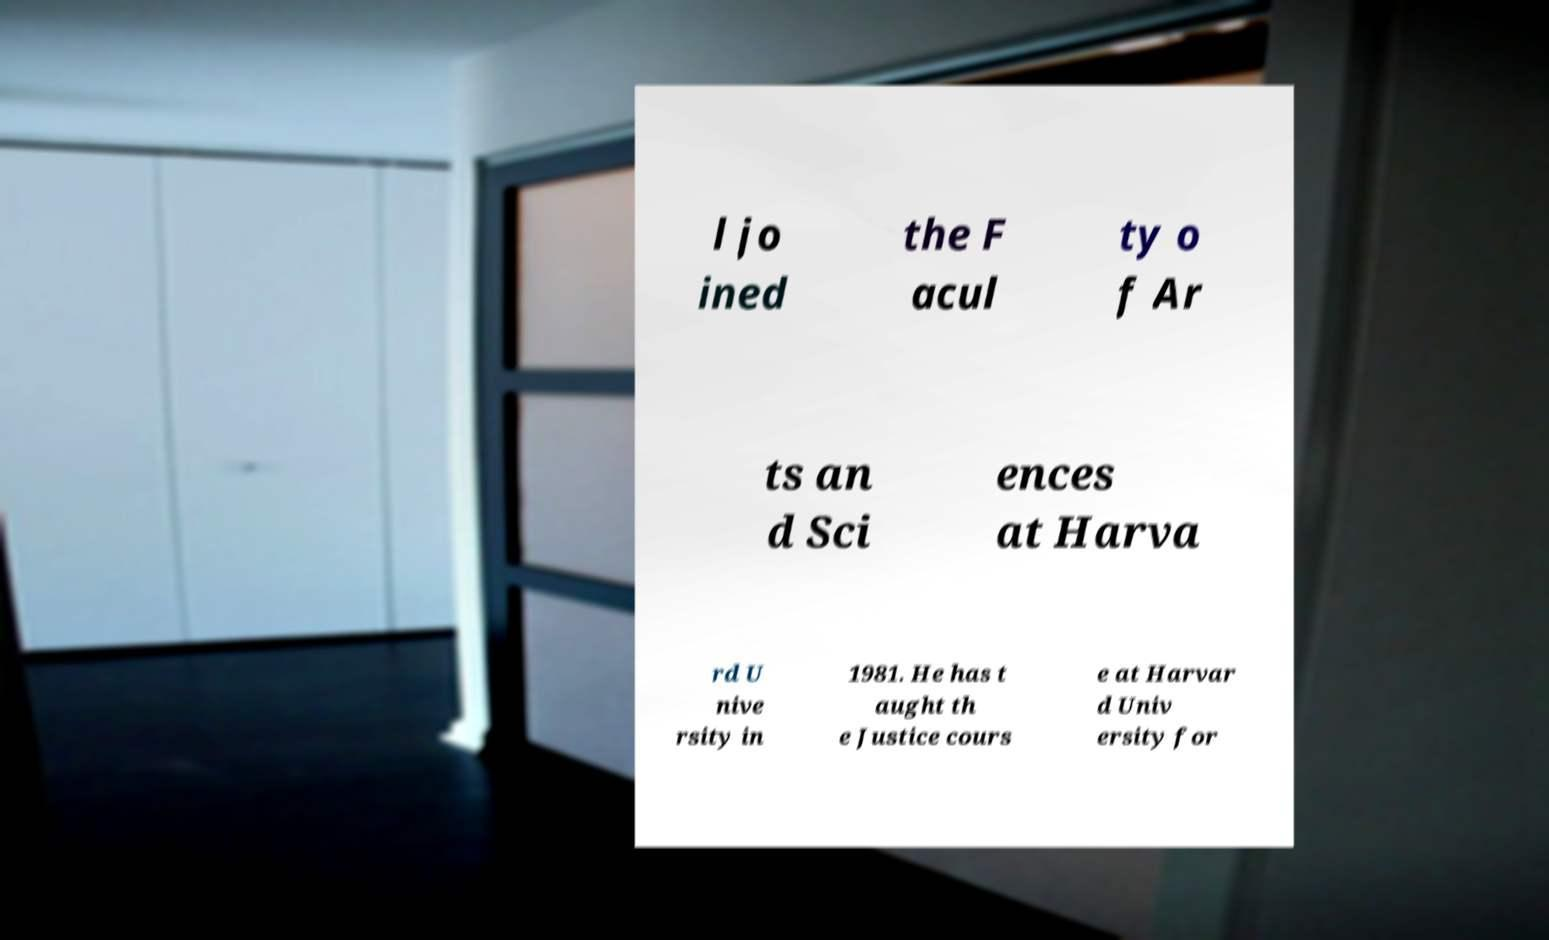Can you read and provide the text displayed in the image?This photo seems to have some interesting text. Can you extract and type it out for me? l jo ined the F acul ty o f Ar ts an d Sci ences at Harva rd U nive rsity in 1981. He has t aught th e Justice cours e at Harvar d Univ ersity for 